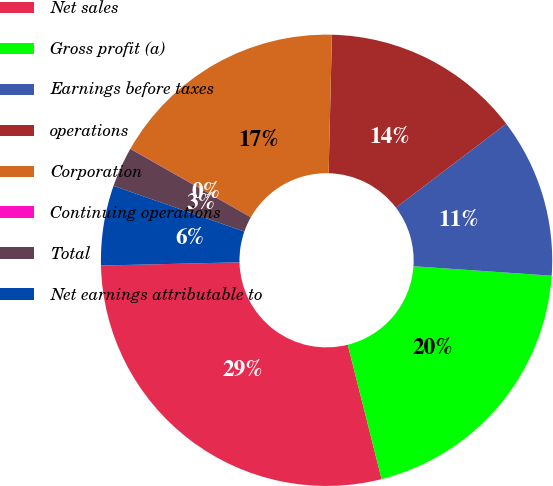Convert chart. <chart><loc_0><loc_0><loc_500><loc_500><pie_chart><fcel>Net sales<fcel>Gross profit (a)<fcel>Earnings before taxes<fcel>operations<fcel>Corporation<fcel>Continuing operations<fcel>Total<fcel>Net earnings attributable to<nl><fcel>28.55%<fcel>19.99%<fcel>11.43%<fcel>14.28%<fcel>17.14%<fcel>0.02%<fcel>2.87%<fcel>5.72%<nl></chart> 